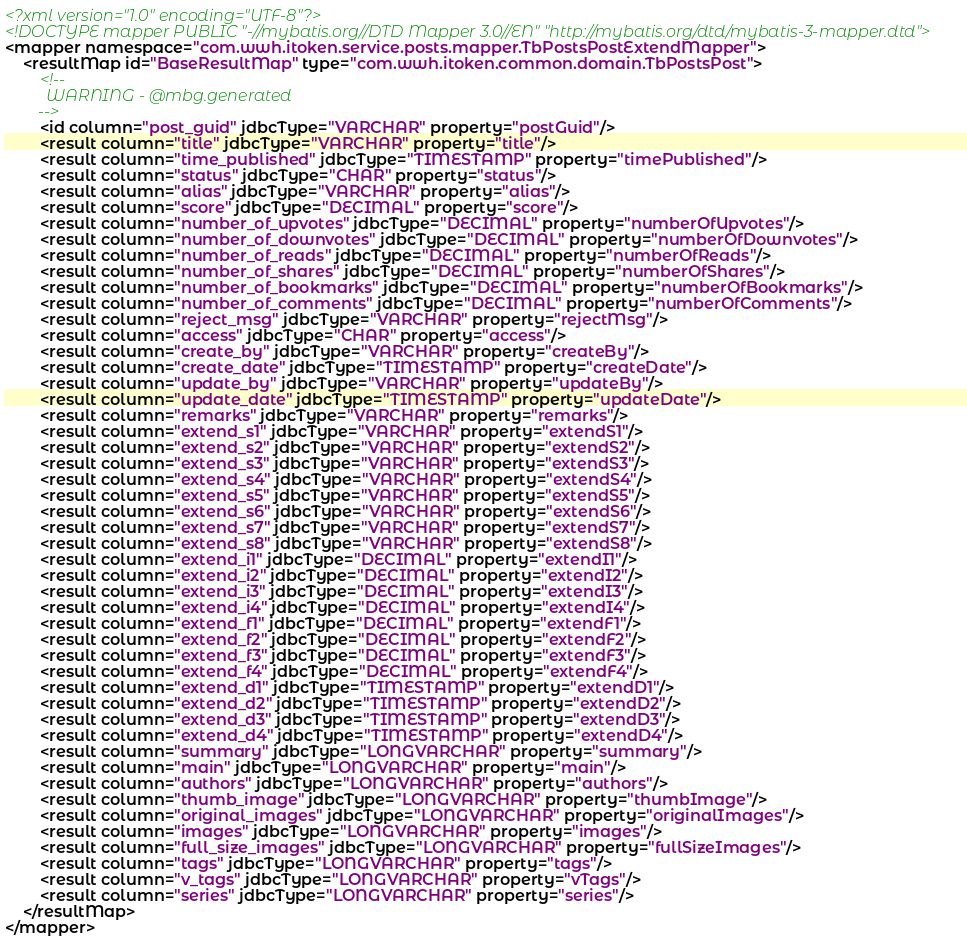Convert code to text. <code><loc_0><loc_0><loc_500><loc_500><_XML_><?xml version="1.0" encoding="UTF-8"?>
<!DOCTYPE mapper PUBLIC "-//mybatis.org//DTD Mapper 3.0//EN" "http://mybatis.org/dtd/mybatis-3-mapper.dtd">
<mapper namespace="com.wwh.itoken.service.posts.mapper.TbPostsPostExtendMapper">
    <resultMap id="BaseResultMap" type="com.wwh.itoken.common.domain.TbPostsPost">
        <!--
          WARNING - @mbg.generated
        -->
        <id column="post_guid" jdbcType="VARCHAR" property="postGuid"/>
        <result column="title" jdbcType="VARCHAR" property="title"/>
        <result column="time_published" jdbcType="TIMESTAMP" property="timePublished"/>
        <result column="status" jdbcType="CHAR" property="status"/>
        <result column="alias" jdbcType="VARCHAR" property="alias"/>
        <result column="score" jdbcType="DECIMAL" property="score"/>
        <result column="number_of_upvotes" jdbcType="DECIMAL" property="numberOfUpvotes"/>
        <result column="number_of_downvotes" jdbcType="DECIMAL" property="numberOfDownvotes"/>
        <result column="number_of_reads" jdbcType="DECIMAL" property="numberOfReads"/>
        <result column="number_of_shares" jdbcType="DECIMAL" property="numberOfShares"/>
        <result column="number_of_bookmarks" jdbcType="DECIMAL" property="numberOfBookmarks"/>
        <result column="number_of_comments" jdbcType="DECIMAL" property="numberOfComments"/>
        <result column="reject_msg" jdbcType="VARCHAR" property="rejectMsg"/>
        <result column="access" jdbcType="CHAR" property="access"/>
        <result column="create_by" jdbcType="VARCHAR" property="createBy"/>
        <result column="create_date" jdbcType="TIMESTAMP" property="createDate"/>
        <result column="update_by" jdbcType="VARCHAR" property="updateBy"/>
        <result column="update_date" jdbcType="TIMESTAMP" property="updateDate"/>
        <result column="remarks" jdbcType="VARCHAR" property="remarks"/>
        <result column="extend_s1" jdbcType="VARCHAR" property="extendS1"/>
        <result column="extend_s2" jdbcType="VARCHAR" property="extendS2"/>
        <result column="extend_s3" jdbcType="VARCHAR" property="extendS3"/>
        <result column="extend_s4" jdbcType="VARCHAR" property="extendS4"/>
        <result column="extend_s5" jdbcType="VARCHAR" property="extendS5"/>
        <result column="extend_s6" jdbcType="VARCHAR" property="extendS6"/>
        <result column="extend_s7" jdbcType="VARCHAR" property="extendS7"/>
        <result column="extend_s8" jdbcType="VARCHAR" property="extendS8"/>
        <result column="extend_i1" jdbcType="DECIMAL" property="extendI1"/>
        <result column="extend_i2" jdbcType="DECIMAL" property="extendI2"/>
        <result column="extend_i3" jdbcType="DECIMAL" property="extendI3"/>
        <result column="extend_i4" jdbcType="DECIMAL" property="extendI4"/>
        <result column="extend_f1" jdbcType="DECIMAL" property="extendF1"/>
        <result column="extend_f2" jdbcType="DECIMAL" property="extendF2"/>
        <result column="extend_f3" jdbcType="DECIMAL" property="extendF3"/>
        <result column="extend_f4" jdbcType="DECIMAL" property="extendF4"/>
        <result column="extend_d1" jdbcType="TIMESTAMP" property="extendD1"/>
        <result column="extend_d2" jdbcType="TIMESTAMP" property="extendD2"/>
        <result column="extend_d3" jdbcType="TIMESTAMP" property="extendD3"/>
        <result column="extend_d4" jdbcType="TIMESTAMP" property="extendD4"/>
        <result column="summary" jdbcType="LONGVARCHAR" property="summary"/>
        <result column="main" jdbcType="LONGVARCHAR" property="main"/>
        <result column="authors" jdbcType="LONGVARCHAR" property="authors"/>
        <result column="thumb_image" jdbcType="LONGVARCHAR" property="thumbImage"/>
        <result column="original_images" jdbcType="LONGVARCHAR" property="originalImages"/>
        <result column="images" jdbcType="LONGVARCHAR" property="images"/>
        <result column="full_size_images" jdbcType="LONGVARCHAR" property="fullSizeImages"/>
        <result column="tags" jdbcType="LONGVARCHAR" property="tags"/>
        <result column="v_tags" jdbcType="LONGVARCHAR" property="vTags"/>
        <result column="series" jdbcType="LONGVARCHAR" property="series"/>
    </resultMap>
</mapper></code> 